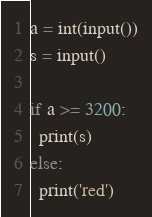Convert code to text. <code><loc_0><loc_0><loc_500><loc_500><_Python_>a = int(input())
s = input()

if a >= 3200:
  print(s)
else:
  print('red')</code> 